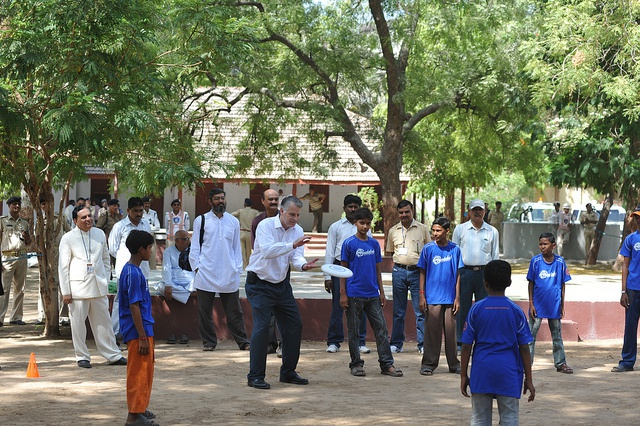Describe the objects in this image and their specific colors. I can see people in green, navy, black, darkblue, and gray tones, people in green, black, darkgray, and lavender tones, people in green, black, lightblue, and darkgray tones, people in green, darkgray, black, and lavender tones, and people in green, darkgray, lightgray, and gray tones in this image. 